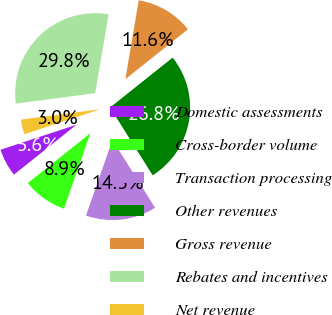Convert chart. <chart><loc_0><loc_0><loc_500><loc_500><pie_chart><fcel>Domestic assessments<fcel>Cross-border volume<fcel>Transaction processing<fcel>Other revenues<fcel>Gross revenue<fcel>Rebates and incentives<fcel>Net revenue<nl><fcel>5.65%<fcel>8.93%<fcel>14.29%<fcel>26.79%<fcel>11.61%<fcel>29.76%<fcel>2.98%<nl></chart> 